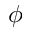Convert formula to latex. <formula><loc_0><loc_0><loc_500><loc_500>\phi</formula> 